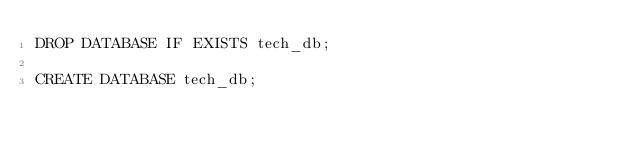<code> <loc_0><loc_0><loc_500><loc_500><_SQL_>DROP DATABASE IF EXISTS tech_db;

CREATE DATABASE tech_db;
</code> 